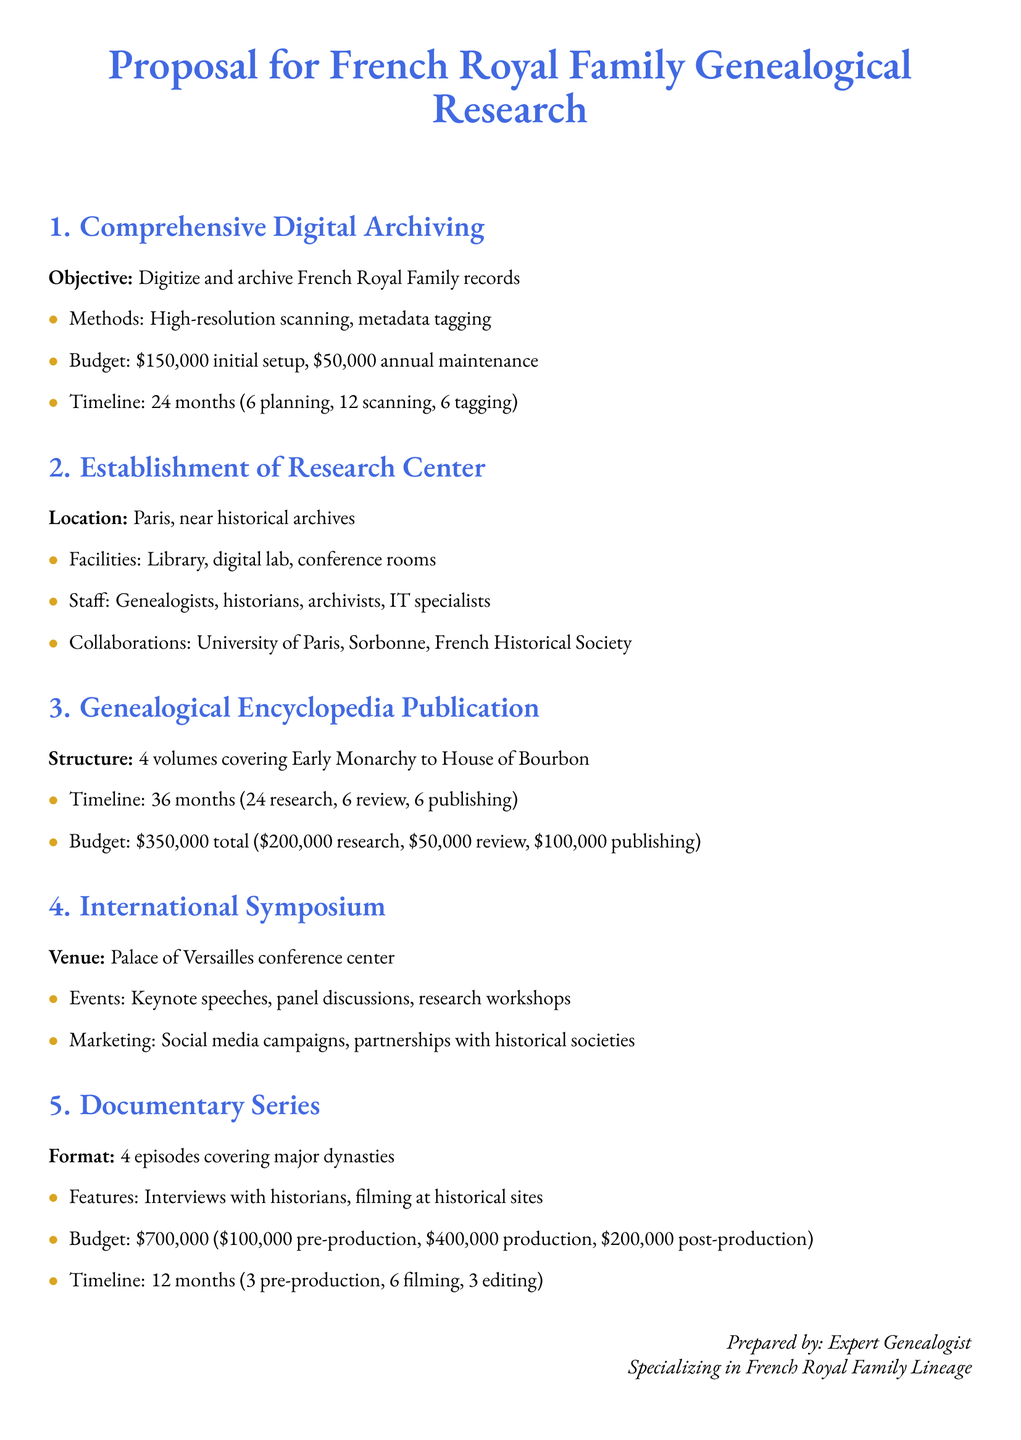What is the initial setup budget for the digital archiving? The initial setup budget for the digital archiving is stated in the document.
Answer: $150,000 How long is the timeline for the genealogical encyclopedia publication? The timeline for the genealogical encyclopedia publication is a combination of research, review, and publishing periods listed in the document.
Answer: 36 months What location is proposed for the research center? The proposed location for the research center is mentioned in the document.
Answer: Paris How many volumes will the genealogical encyclopedia contain? The document specifies the structure of the genealogical encyclopedia in terms of volume count.
Answer: 4 volumes What type of events are planned for the international symposium? The document outlines types of events included in the symposium proposal.
Answer: Keynote speeches, panel discussions, research workshops What is the total budget for the documentary series? The total budget for the documentary series is calculated from the detailed budget breakdown provided in the proposal.
Answer: $700,000 Who are potential collaborators listed for the research center? The document mentions specific potential collaborations for the establishment of the research center.
Answer: University of Paris, Sorbonne, French Historical Society What is the proposed duration for the comprehensive digital archiving project? The proposed duration for the comprehensive digital archiving project includes planning, scanning, and tagging phases outlined in the document.
Answer: 24 months 